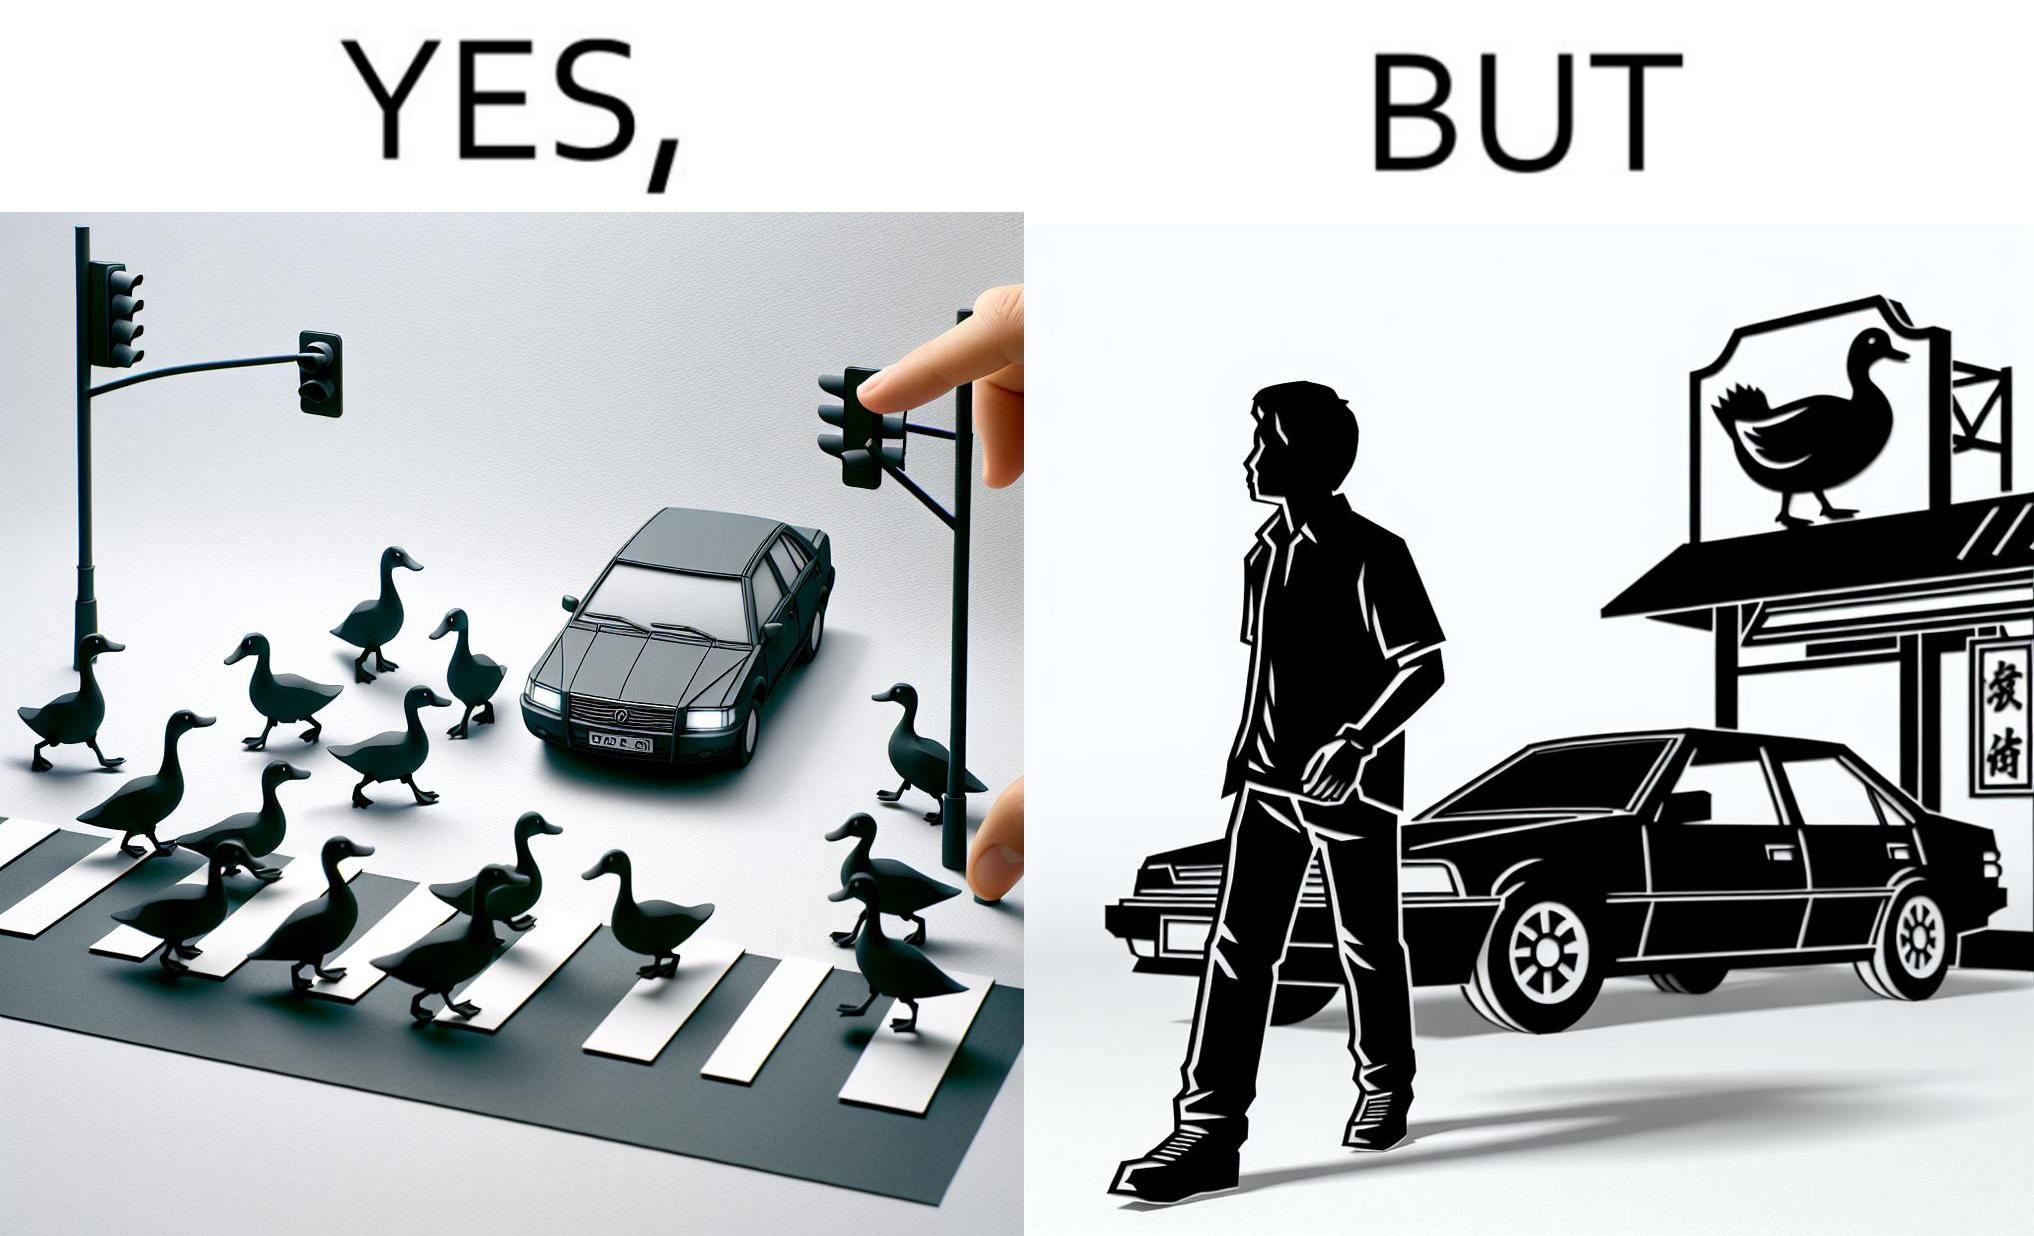Provide a description of this image. The images are ironic since they show how a man supposedly cares for ducks since he stops his vehicle to give way to queue of ducks allowing them to safely cross a road but on the other hand he goes to a peking duck shop to buy and eat similar ducks after having them killed 